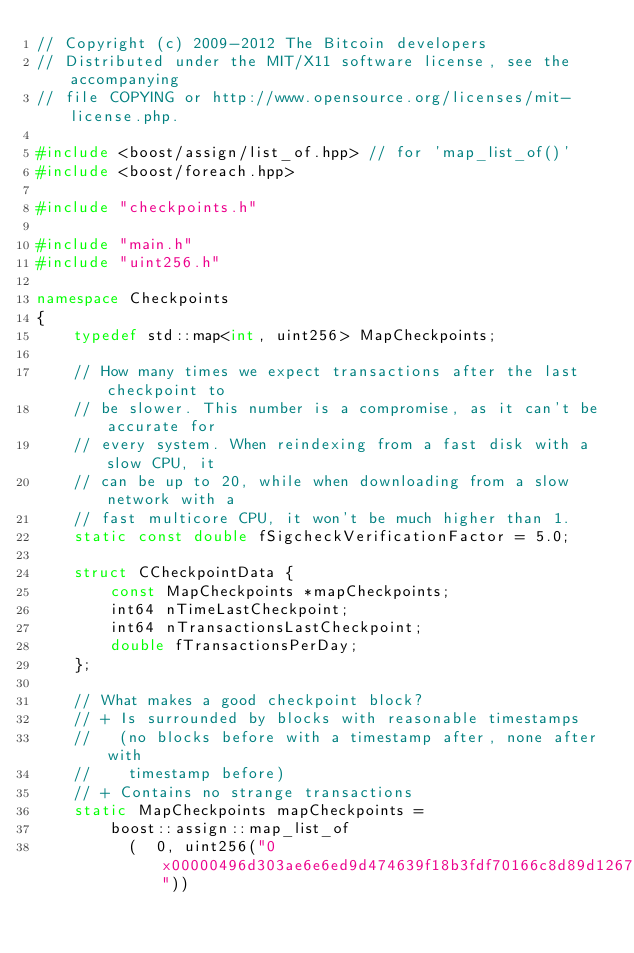<code> <loc_0><loc_0><loc_500><loc_500><_C++_>// Copyright (c) 2009-2012 The Bitcoin developers
// Distributed under the MIT/X11 software license, see the accompanying
// file COPYING or http://www.opensource.org/licenses/mit-license.php.

#include <boost/assign/list_of.hpp> // for 'map_list_of()'
#include <boost/foreach.hpp>

#include "checkpoints.h"

#include "main.h"
#include "uint256.h"

namespace Checkpoints
{
    typedef std::map<int, uint256> MapCheckpoints;

    // How many times we expect transactions after the last checkpoint to
    // be slower. This number is a compromise, as it can't be accurate for
    // every system. When reindexing from a fast disk with a slow CPU, it
    // can be up to 20, while when downloading from a slow network with a
    // fast multicore CPU, it won't be much higher than 1.
    static const double fSigcheckVerificationFactor = 5.0;

    struct CCheckpointData {
        const MapCheckpoints *mapCheckpoints;
        int64 nTimeLastCheckpoint;
        int64 nTransactionsLastCheckpoint;
        double fTransactionsPerDay;
    };

    // What makes a good checkpoint block?
    // + Is surrounded by blocks with reasonable timestamps
    //   (no blocks before with a timestamp after, none after with
    //    timestamp before)
    // + Contains no strange transactions
    static MapCheckpoints mapCheckpoints =
        boost::assign::map_list_of
	      (  0, uint256("0x00000496d303ae6e6ed9d474639f18b3fdf70166c8d89d1267bbf5fd640e1690"))</code> 